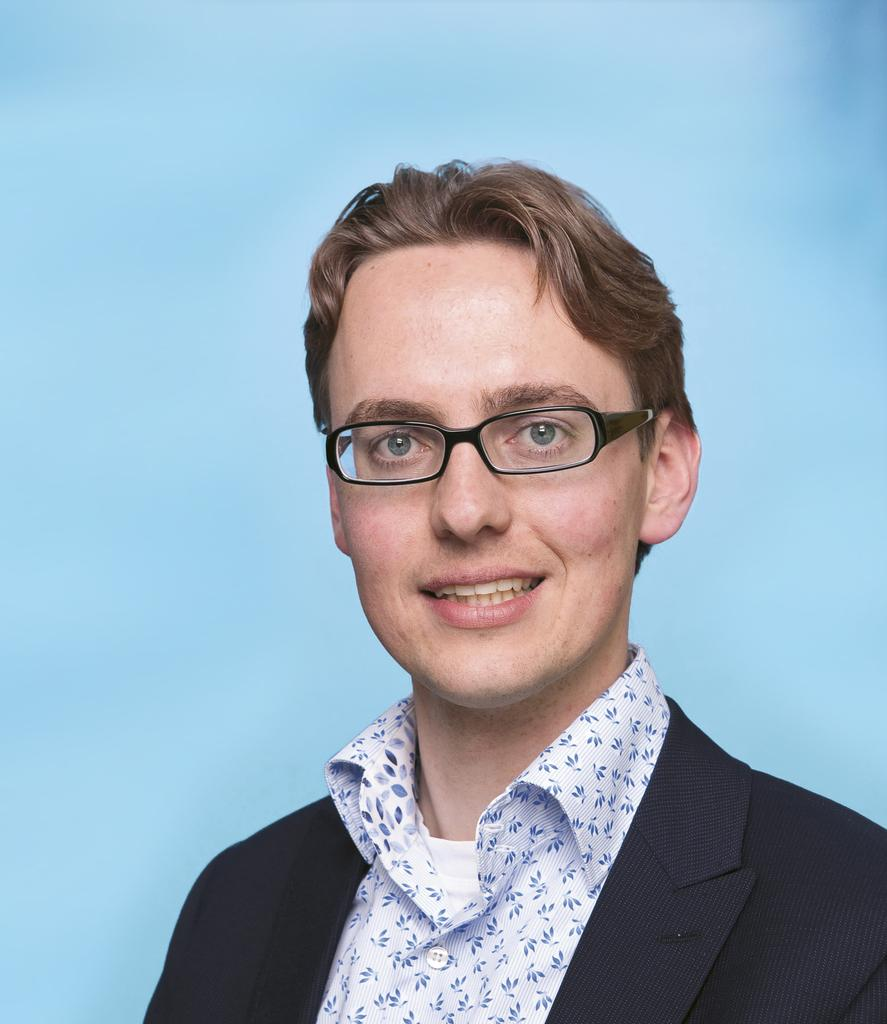Who is the main subject in the image? There is a man in the image. Where is the man located in the image? The man is in the front of the image. What is the man's facial expression in the image? The man is smiling. What type of company is the man representing in the image? There is no indication of a company or any affiliation in the image. How many pizzas is the man holding in the image? There are no pizzas present in the image. 